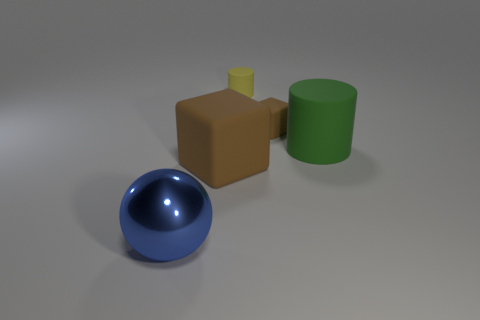Is the number of brown things that are behind the green object greater than the number of small brown blocks to the left of the blue shiny object?
Your answer should be very brief. Yes. There is a big blue sphere; what number of large objects are right of it?
Offer a very short reply. 2. Is the large brown block made of the same material as the brown cube to the right of the yellow cylinder?
Your answer should be compact. Yes. Is there any other thing that is the same shape as the large blue metallic object?
Your answer should be very brief. No. Is the material of the green cylinder the same as the big blue ball?
Give a very brief answer. No. Are there any tiny brown rubber cubes that are left of the big object that is on the left side of the large brown block?
Provide a short and direct response. No. What number of brown cubes are both on the left side of the tiny yellow matte cylinder and on the right side of the tiny cylinder?
Your response must be concise. 0. There is a big rubber thing that is to the right of the small yellow cylinder; what shape is it?
Provide a short and direct response. Cylinder. How many green things have the same size as the blue shiny sphere?
Provide a short and direct response. 1. There is a big object to the right of the small brown matte object; does it have the same color as the big shiny object?
Your answer should be very brief. No. 